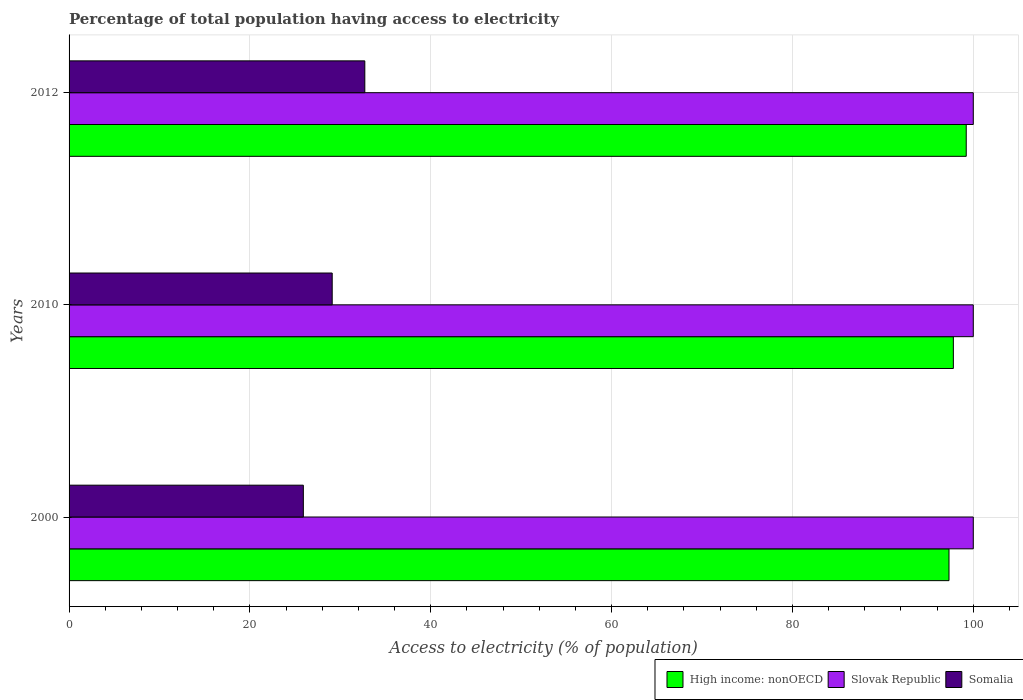How many groups of bars are there?
Offer a terse response. 3. Are the number of bars per tick equal to the number of legend labels?
Keep it short and to the point. Yes. How many bars are there on the 3rd tick from the top?
Make the answer very short. 3. How many bars are there on the 2nd tick from the bottom?
Make the answer very short. 3. What is the label of the 1st group of bars from the top?
Make the answer very short. 2012. In how many cases, is the number of bars for a given year not equal to the number of legend labels?
Offer a very short reply. 0. What is the percentage of population that have access to electricity in Slovak Republic in 2012?
Ensure brevity in your answer.  100. Across all years, what is the maximum percentage of population that have access to electricity in Somalia?
Keep it short and to the point. 32.71. Across all years, what is the minimum percentage of population that have access to electricity in Slovak Republic?
Your answer should be compact. 100. In which year was the percentage of population that have access to electricity in Slovak Republic minimum?
Make the answer very short. 2000. What is the total percentage of population that have access to electricity in Slovak Republic in the graph?
Your answer should be compact. 300. What is the difference between the percentage of population that have access to electricity in High income: nonOECD in 2000 and that in 2012?
Your response must be concise. -1.91. What is the difference between the percentage of population that have access to electricity in High income: nonOECD in 2010 and the percentage of population that have access to electricity in Somalia in 2012?
Make the answer very short. 65.09. What is the average percentage of population that have access to electricity in High income: nonOECD per year?
Your response must be concise. 98.11. In the year 2012, what is the difference between the percentage of population that have access to electricity in Slovak Republic and percentage of population that have access to electricity in Somalia?
Provide a short and direct response. 67.29. Is the difference between the percentage of population that have access to electricity in Slovak Republic in 2000 and 2010 greater than the difference between the percentage of population that have access to electricity in Somalia in 2000 and 2010?
Offer a terse response. Yes. What is the difference between the highest and the second highest percentage of population that have access to electricity in Slovak Republic?
Provide a succinct answer. 0. What is the difference between the highest and the lowest percentage of population that have access to electricity in Somalia?
Provide a short and direct response. 6.8. In how many years, is the percentage of population that have access to electricity in Somalia greater than the average percentage of population that have access to electricity in Somalia taken over all years?
Give a very brief answer. 1. What does the 2nd bar from the top in 2012 represents?
Make the answer very short. Slovak Republic. What does the 3rd bar from the bottom in 2012 represents?
Keep it short and to the point. Somalia. How many bars are there?
Make the answer very short. 9. What is the difference between two consecutive major ticks on the X-axis?
Ensure brevity in your answer.  20. Does the graph contain any zero values?
Offer a very short reply. No. Does the graph contain grids?
Ensure brevity in your answer.  Yes. How many legend labels are there?
Provide a short and direct response. 3. What is the title of the graph?
Offer a very short reply. Percentage of total population having access to electricity. What is the label or title of the X-axis?
Keep it short and to the point. Access to electricity (% of population). What is the label or title of the Y-axis?
Your answer should be compact. Years. What is the Access to electricity (% of population) in High income: nonOECD in 2000?
Offer a terse response. 97.31. What is the Access to electricity (% of population) in Somalia in 2000?
Provide a short and direct response. 25.91. What is the Access to electricity (% of population) in High income: nonOECD in 2010?
Give a very brief answer. 97.8. What is the Access to electricity (% of population) of Somalia in 2010?
Your answer should be compact. 29.1. What is the Access to electricity (% of population) in High income: nonOECD in 2012?
Provide a short and direct response. 99.22. What is the Access to electricity (% of population) in Somalia in 2012?
Keep it short and to the point. 32.71. Across all years, what is the maximum Access to electricity (% of population) of High income: nonOECD?
Your answer should be very brief. 99.22. Across all years, what is the maximum Access to electricity (% of population) in Somalia?
Offer a terse response. 32.71. Across all years, what is the minimum Access to electricity (% of population) of High income: nonOECD?
Provide a short and direct response. 97.31. Across all years, what is the minimum Access to electricity (% of population) in Somalia?
Provide a short and direct response. 25.91. What is the total Access to electricity (% of population) in High income: nonOECD in the graph?
Your answer should be very brief. 294.33. What is the total Access to electricity (% of population) of Slovak Republic in the graph?
Ensure brevity in your answer.  300. What is the total Access to electricity (% of population) of Somalia in the graph?
Keep it short and to the point. 87.72. What is the difference between the Access to electricity (% of population) in High income: nonOECD in 2000 and that in 2010?
Ensure brevity in your answer.  -0.48. What is the difference between the Access to electricity (% of population) of Slovak Republic in 2000 and that in 2010?
Your answer should be very brief. 0. What is the difference between the Access to electricity (% of population) in Somalia in 2000 and that in 2010?
Make the answer very short. -3.19. What is the difference between the Access to electricity (% of population) of High income: nonOECD in 2000 and that in 2012?
Make the answer very short. -1.91. What is the difference between the Access to electricity (% of population) of Slovak Republic in 2000 and that in 2012?
Make the answer very short. 0. What is the difference between the Access to electricity (% of population) in Somalia in 2000 and that in 2012?
Provide a short and direct response. -6.8. What is the difference between the Access to electricity (% of population) in High income: nonOECD in 2010 and that in 2012?
Provide a short and direct response. -1.43. What is the difference between the Access to electricity (% of population) in Slovak Republic in 2010 and that in 2012?
Provide a succinct answer. 0. What is the difference between the Access to electricity (% of population) in Somalia in 2010 and that in 2012?
Your answer should be very brief. -3.61. What is the difference between the Access to electricity (% of population) of High income: nonOECD in 2000 and the Access to electricity (% of population) of Slovak Republic in 2010?
Provide a succinct answer. -2.69. What is the difference between the Access to electricity (% of population) in High income: nonOECD in 2000 and the Access to electricity (% of population) in Somalia in 2010?
Provide a succinct answer. 68.21. What is the difference between the Access to electricity (% of population) of Slovak Republic in 2000 and the Access to electricity (% of population) of Somalia in 2010?
Your answer should be very brief. 70.9. What is the difference between the Access to electricity (% of population) of High income: nonOECD in 2000 and the Access to electricity (% of population) of Slovak Republic in 2012?
Provide a short and direct response. -2.69. What is the difference between the Access to electricity (% of population) of High income: nonOECD in 2000 and the Access to electricity (% of population) of Somalia in 2012?
Provide a short and direct response. 64.61. What is the difference between the Access to electricity (% of population) in Slovak Republic in 2000 and the Access to electricity (% of population) in Somalia in 2012?
Your answer should be very brief. 67.29. What is the difference between the Access to electricity (% of population) of High income: nonOECD in 2010 and the Access to electricity (% of population) of Slovak Republic in 2012?
Offer a very short reply. -2.2. What is the difference between the Access to electricity (% of population) in High income: nonOECD in 2010 and the Access to electricity (% of population) in Somalia in 2012?
Give a very brief answer. 65.09. What is the difference between the Access to electricity (% of population) in Slovak Republic in 2010 and the Access to electricity (% of population) in Somalia in 2012?
Offer a terse response. 67.29. What is the average Access to electricity (% of population) of High income: nonOECD per year?
Your answer should be very brief. 98.11. What is the average Access to electricity (% of population) in Slovak Republic per year?
Provide a succinct answer. 100. What is the average Access to electricity (% of population) in Somalia per year?
Offer a very short reply. 29.24. In the year 2000, what is the difference between the Access to electricity (% of population) of High income: nonOECD and Access to electricity (% of population) of Slovak Republic?
Your answer should be very brief. -2.69. In the year 2000, what is the difference between the Access to electricity (% of population) in High income: nonOECD and Access to electricity (% of population) in Somalia?
Your answer should be compact. 71.4. In the year 2000, what is the difference between the Access to electricity (% of population) of Slovak Republic and Access to electricity (% of population) of Somalia?
Ensure brevity in your answer.  74.09. In the year 2010, what is the difference between the Access to electricity (% of population) in High income: nonOECD and Access to electricity (% of population) in Slovak Republic?
Provide a short and direct response. -2.2. In the year 2010, what is the difference between the Access to electricity (% of population) of High income: nonOECD and Access to electricity (% of population) of Somalia?
Ensure brevity in your answer.  68.7. In the year 2010, what is the difference between the Access to electricity (% of population) of Slovak Republic and Access to electricity (% of population) of Somalia?
Offer a very short reply. 70.9. In the year 2012, what is the difference between the Access to electricity (% of population) of High income: nonOECD and Access to electricity (% of population) of Slovak Republic?
Give a very brief answer. -0.78. In the year 2012, what is the difference between the Access to electricity (% of population) in High income: nonOECD and Access to electricity (% of population) in Somalia?
Your response must be concise. 66.51. In the year 2012, what is the difference between the Access to electricity (% of population) of Slovak Republic and Access to electricity (% of population) of Somalia?
Give a very brief answer. 67.29. What is the ratio of the Access to electricity (% of population) of High income: nonOECD in 2000 to that in 2010?
Ensure brevity in your answer.  1. What is the ratio of the Access to electricity (% of population) of Slovak Republic in 2000 to that in 2010?
Your response must be concise. 1. What is the ratio of the Access to electricity (% of population) of Somalia in 2000 to that in 2010?
Keep it short and to the point. 0.89. What is the ratio of the Access to electricity (% of population) of High income: nonOECD in 2000 to that in 2012?
Ensure brevity in your answer.  0.98. What is the ratio of the Access to electricity (% of population) of Slovak Republic in 2000 to that in 2012?
Ensure brevity in your answer.  1. What is the ratio of the Access to electricity (% of population) in Somalia in 2000 to that in 2012?
Make the answer very short. 0.79. What is the ratio of the Access to electricity (% of population) of High income: nonOECD in 2010 to that in 2012?
Your answer should be compact. 0.99. What is the ratio of the Access to electricity (% of population) of Slovak Republic in 2010 to that in 2012?
Provide a short and direct response. 1. What is the ratio of the Access to electricity (% of population) in Somalia in 2010 to that in 2012?
Give a very brief answer. 0.89. What is the difference between the highest and the second highest Access to electricity (% of population) in High income: nonOECD?
Your answer should be compact. 1.43. What is the difference between the highest and the second highest Access to electricity (% of population) of Somalia?
Provide a succinct answer. 3.61. What is the difference between the highest and the lowest Access to electricity (% of population) of High income: nonOECD?
Offer a terse response. 1.91. What is the difference between the highest and the lowest Access to electricity (% of population) in Slovak Republic?
Make the answer very short. 0. What is the difference between the highest and the lowest Access to electricity (% of population) in Somalia?
Make the answer very short. 6.8. 